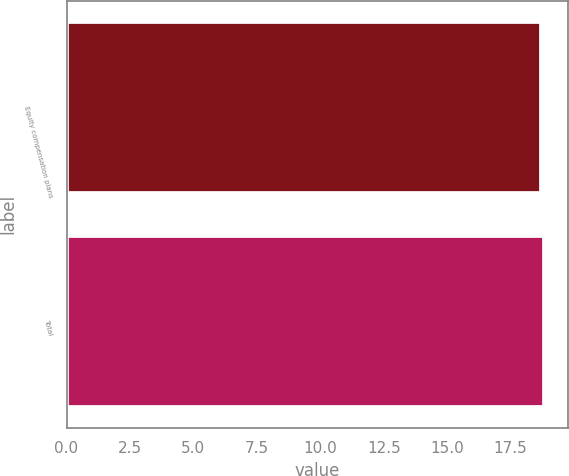Convert chart to OTSL. <chart><loc_0><loc_0><loc_500><loc_500><bar_chart><fcel>Equity compensation plans<fcel>Total<nl><fcel>18.71<fcel>18.81<nl></chart> 